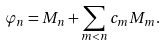Convert formula to latex. <formula><loc_0><loc_0><loc_500><loc_500>\varphi _ { n } = M _ { n } + \sum _ { m < n } c _ { m } M _ { m } .</formula> 